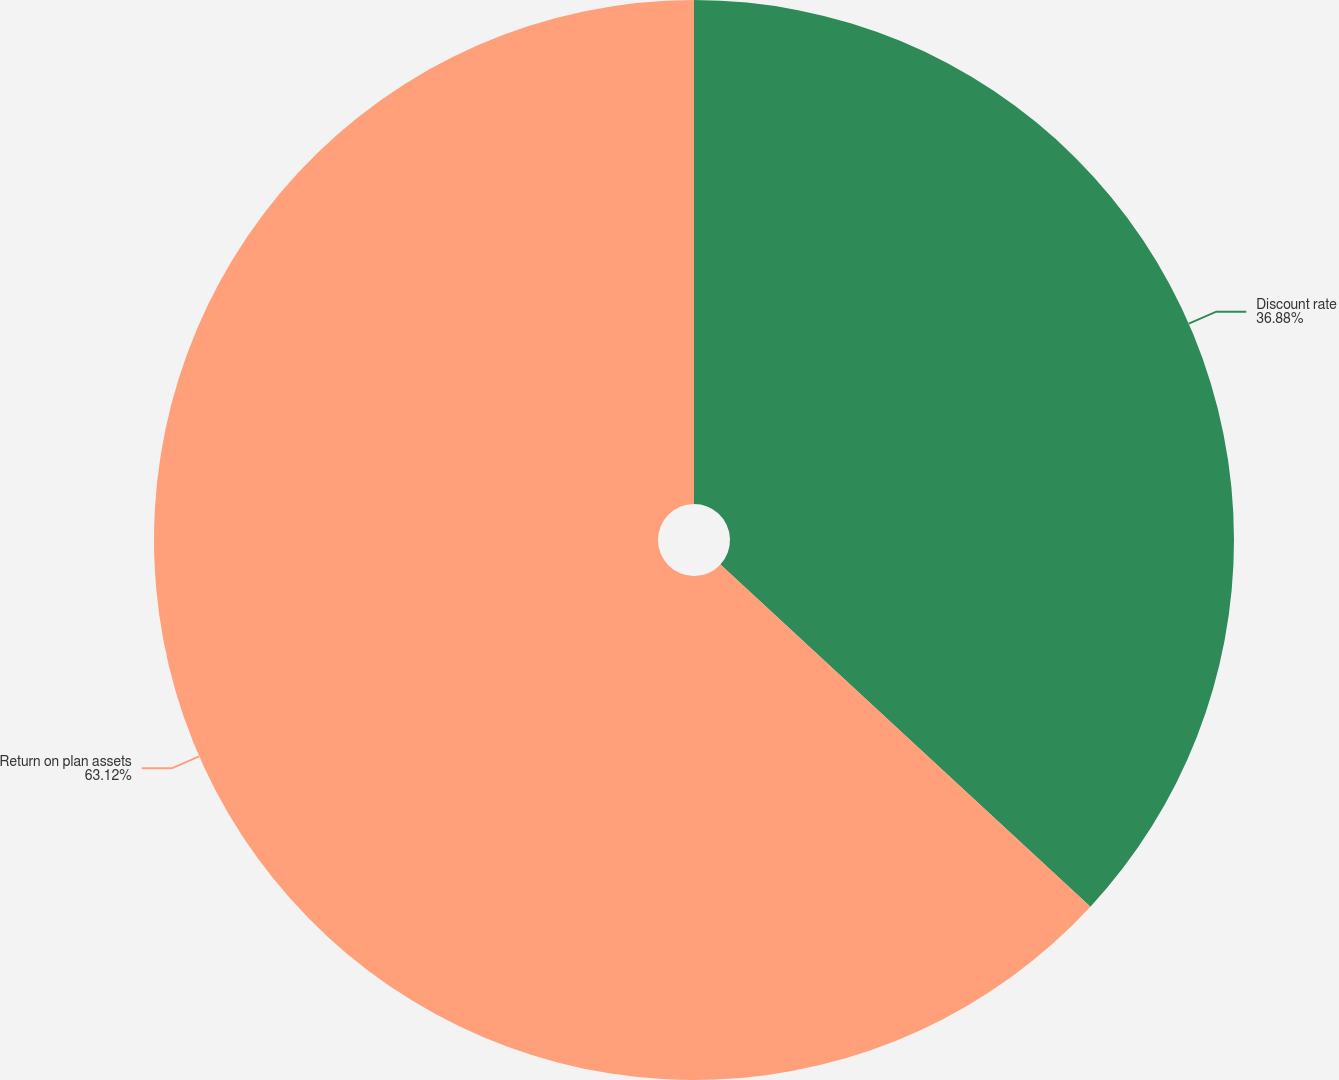Convert chart. <chart><loc_0><loc_0><loc_500><loc_500><pie_chart><fcel>Discount rate<fcel>Return on plan assets<nl><fcel>36.88%<fcel>63.12%<nl></chart> 